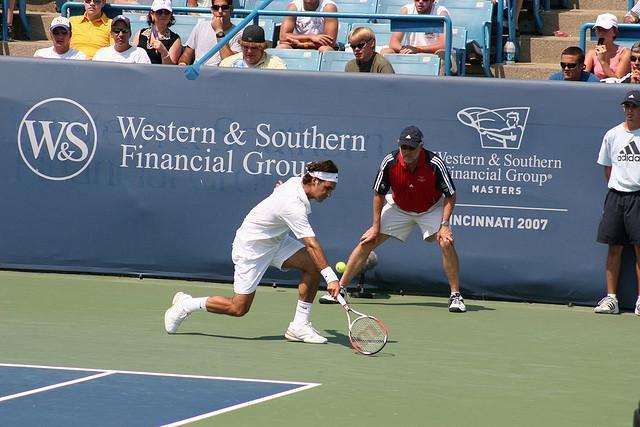How many people are in the picture?
Give a very brief answer. 6. How many people are wearing orange glasses?
Give a very brief answer. 0. 